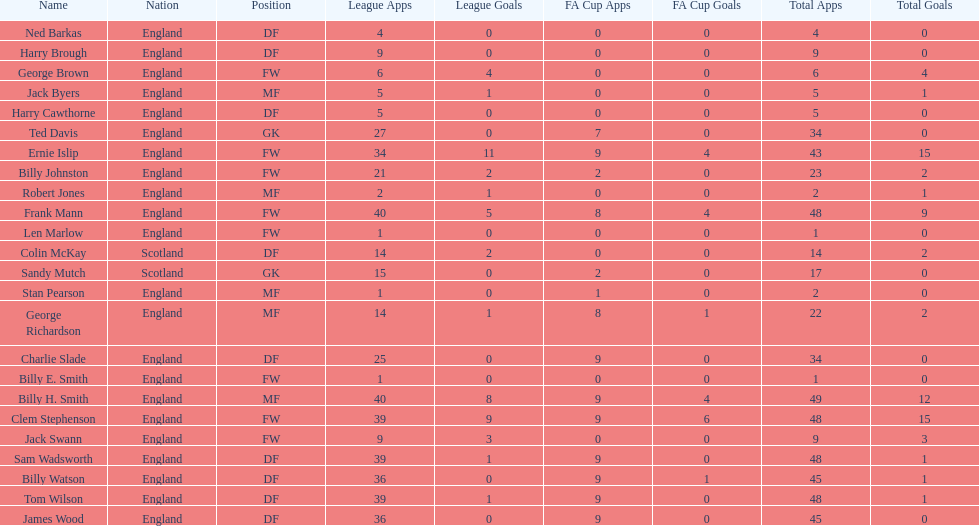What is the first name listed? Ned Barkas. 